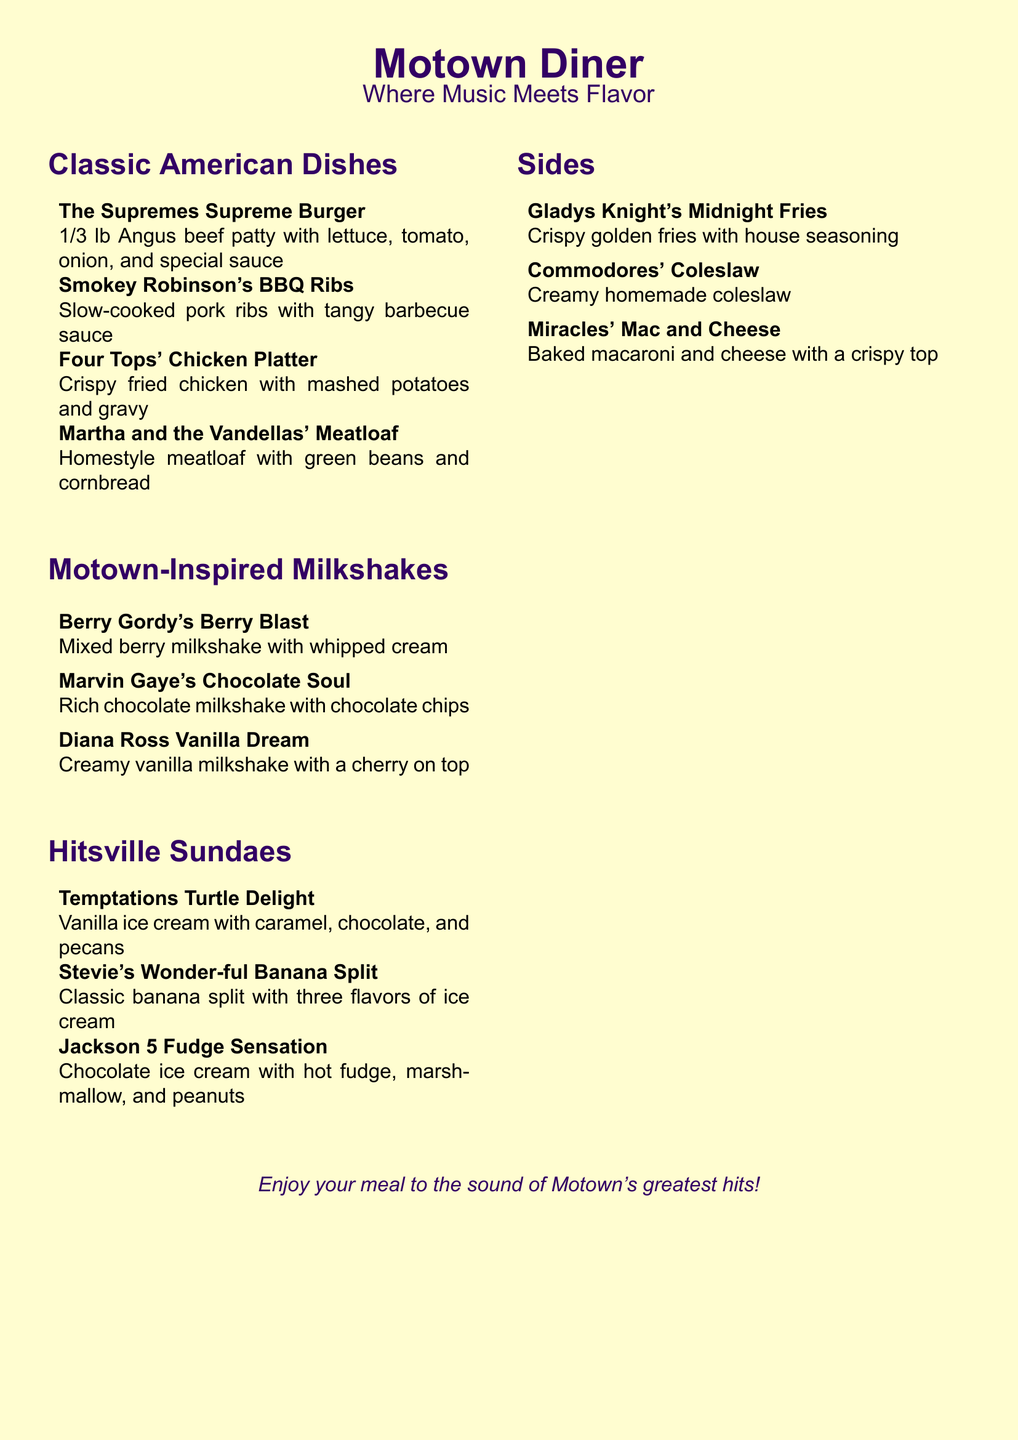What is the name of the burger? The name of the burger is listed as "The Supremes Supreme Burger" in the menu.
Answer: The Supremes Supreme Burger How many types of Motown-inspired milkshakes are there? The menu lists three different Motown-inspired milkshakes under the relevant section.
Answer: 3 What dish comes with green beans and cornbread? The menu specifies that "Martha and the Vandellas' Meatloaf" is served with green beans and cornbread.
Answer: Martha and the Vandellas' Meatloaf Which dessert features chocolate ice cream? The dessert "Jackson 5 Fudge Sensation" features chocolate ice cream.
Answer: Jackson 5 Fudge Sensation What is the special milkshake named after Marvin Gaye? The milkshake named after Marvin Gaye is "Marvin Gaye's Chocolate Soul" according to the menu.
Answer: Marvin Gaye's Chocolate Soul Which side is described as "Crispy golden fries"? The side described as "Crispy golden fries" on the menu is "Gladys Knight's Midnight Fries."
Answer: Gladys Knight's Midnight Fries What is the theme of the diner? The theme of the diner is inspired by Motown music, as indicated in the title and tagline.
Answer: Motown music What type of ice cream is used in the "Stevie's Wonder-ful Banana Split"? The menu mentions that the "Stevie's Wonder-ful Banana Split" includes three flavors of ice cream.
Answer: Three flavors of ice cream 